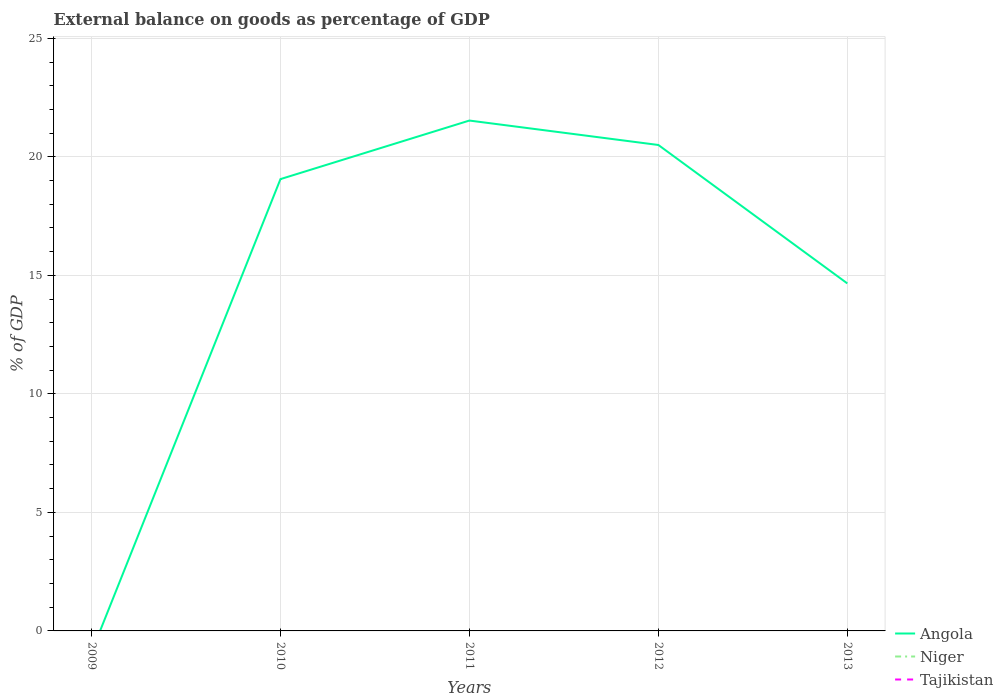What is the total external balance on goods as percentage of GDP in Angola in the graph?
Keep it short and to the point. -2.47. Is the external balance on goods as percentage of GDP in Tajikistan strictly greater than the external balance on goods as percentage of GDP in Angola over the years?
Give a very brief answer. Yes. Does the graph contain grids?
Provide a succinct answer. Yes. Where does the legend appear in the graph?
Your answer should be compact. Bottom right. What is the title of the graph?
Provide a succinct answer. External balance on goods as percentage of GDP. What is the label or title of the Y-axis?
Offer a terse response. % of GDP. What is the % of GDP in Angola in 2009?
Give a very brief answer. 0. What is the % of GDP of Angola in 2010?
Your response must be concise. 19.06. What is the % of GDP in Niger in 2010?
Your answer should be very brief. 0. What is the % of GDP of Angola in 2011?
Your answer should be compact. 21.53. What is the % of GDP in Tajikistan in 2011?
Provide a succinct answer. 0. What is the % of GDP of Angola in 2012?
Provide a short and direct response. 20.5. What is the % of GDP of Niger in 2012?
Offer a terse response. 0. What is the % of GDP in Tajikistan in 2012?
Offer a very short reply. 0. What is the % of GDP of Angola in 2013?
Provide a short and direct response. 14.66. What is the % of GDP in Tajikistan in 2013?
Keep it short and to the point. 0. Across all years, what is the maximum % of GDP of Angola?
Your answer should be compact. 21.53. What is the total % of GDP in Angola in the graph?
Offer a very short reply. 75.75. What is the total % of GDP of Tajikistan in the graph?
Your response must be concise. 0. What is the difference between the % of GDP of Angola in 2010 and that in 2011?
Offer a terse response. -2.47. What is the difference between the % of GDP in Angola in 2010 and that in 2012?
Offer a terse response. -1.44. What is the difference between the % of GDP in Angola in 2010 and that in 2013?
Make the answer very short. 4.4. What is the difference between the % of GDP of Angola in 2011 and that in 2012?
Make the answer very short. 1.03. What is the difference between the % of GDP in Angola in 2011 and that in 2013?
Make the answer very short. 6.87. What is the difference between the % of GDP of Angola in 2012 and that in 2013?
Make the answer very short. 5.84. What is the average % of GDP in Angola per year?
Make the answer very short. 15.15. What is the average % of GDP in Tajikistan per year?
Offer a very short reply. 0. What is the ratio of the % of GDP of Angola in 2010 to that in 2011?
Ensure brevity in your answer.  0.89. What is the ratio of the % of GDP in Angola in 2010 to that in 2012?
Ensure brevity in your answer.  0.93. What is the ratio of the % of GDP in Angola in 2010 to that in 2013?
Your answer should be very brief. 1.3. What is the ratio of the % of GDP of Angola in 2011 to that in 2012?
Offer a terse response. 1.05. What is the ratio of the % of GDP of Angola in 2011 to that in 2013?
Make the answer very short. 1.47. What is the ratio of the % of GDP in Angola in 2012 to that in 2013?
Ensure brevity in your answer.  1.4. What is the difference between the highest and the second highest % of GDP in Angola?
Offer a very short reply. 1.03. What is the difference between the highest and the lowest % of GDP in Angola?
Give a very brief answer. 21.53. 